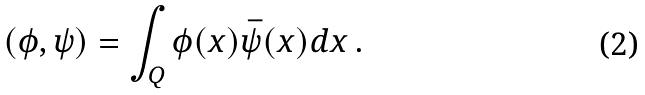<formula> <loc_0><loc_0><loc_500><loc_500>( \phi , \psi ) = \int _ { Q } \phi ( x ) \bar { \psi } ( x ) d x \, .</formula> 